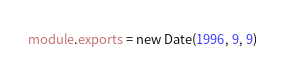Convert code to text. <code><loc_0><loc_0><loc_500><loc_500><_JavaScript_>module.exports = new Date(1996, 9, 9)
</code> 